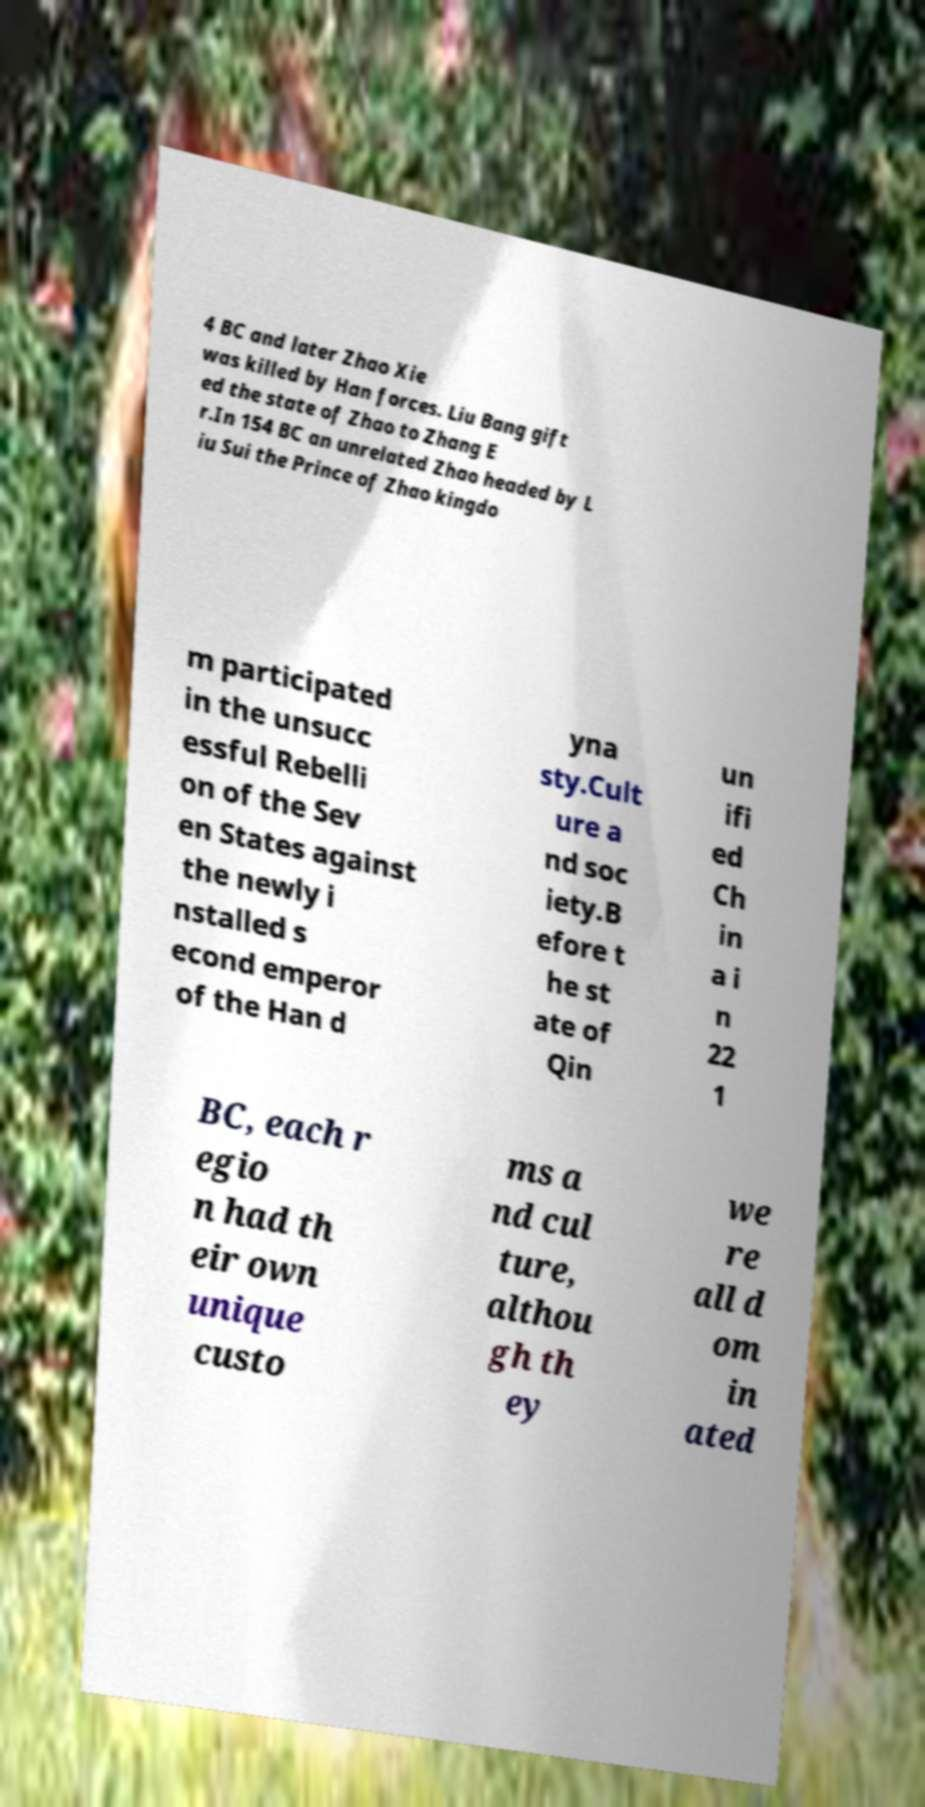What messages or text are displayed in this image? I need them in a readable, typed format. 4 BC and later Zhao Xie was killed by Han forces. Liu Bang gift ed the state of Zhao to Zhang E r.In 154 BC an unrelated Zhao headed by L iu Sui the Prince of Zhao kingdo m participated in the unsucc essful Rebelli on of the Sev en States against the newly i nstalled s econd emperor of the Han d yna sty.Cult ure a nd soc iety.B efore t he st ate of Qin un ifi ed Ch in a i n 22 1 BC, each r egio n had th eir own unique custo ms a nd cul ture, althou gh th ey we re all d om in ated 